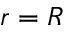Convert formula to latex. <formula><loc_0><loc_0><loc_500><loc_500>r = R</formula> 